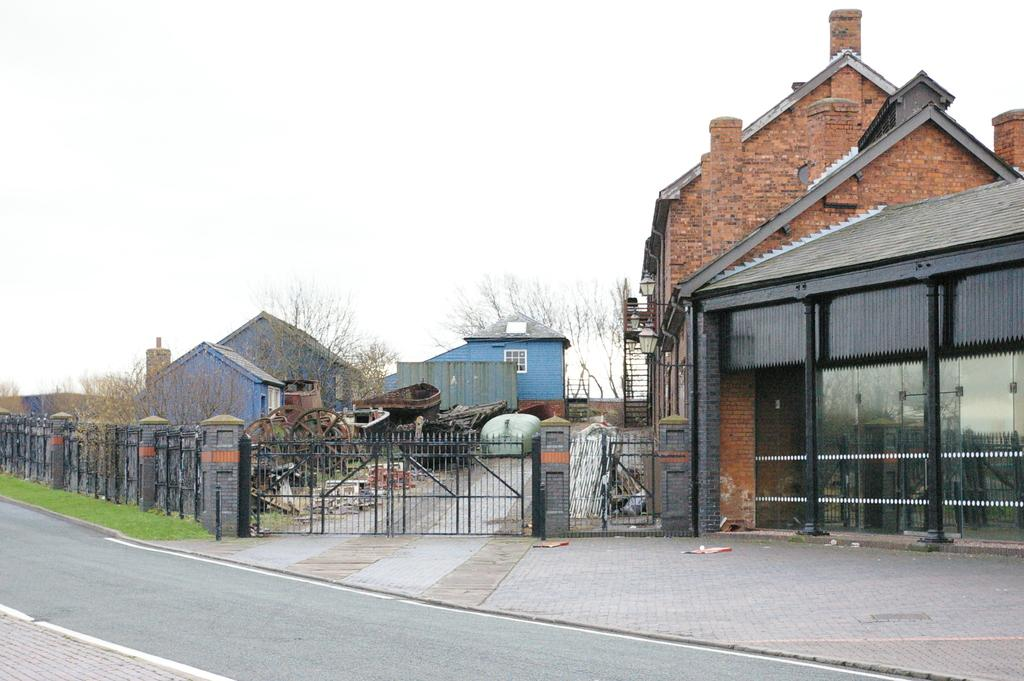What type of pathway is visible in the image? There is a road in the image. What structure can be seen near the road? There is a gate in the image. What type of barrier is present in the image? There are fences in the image. What type of buildings can be seen in the image? There are houses in the image. What type of vehicle is present in the image? There is a cart in the image. What type of vegetation is present in the image? There is grass and trees in the image. What can be seen in the background of the image? The sky is visible in the background of the image. Where is the lock located in the image? There is no lock present in the image. What type of mechanism is present on the cart in the image? There is no brake mechanism present on the cart in the image. What type of flag is present in the image? There is no flag present in the image. 